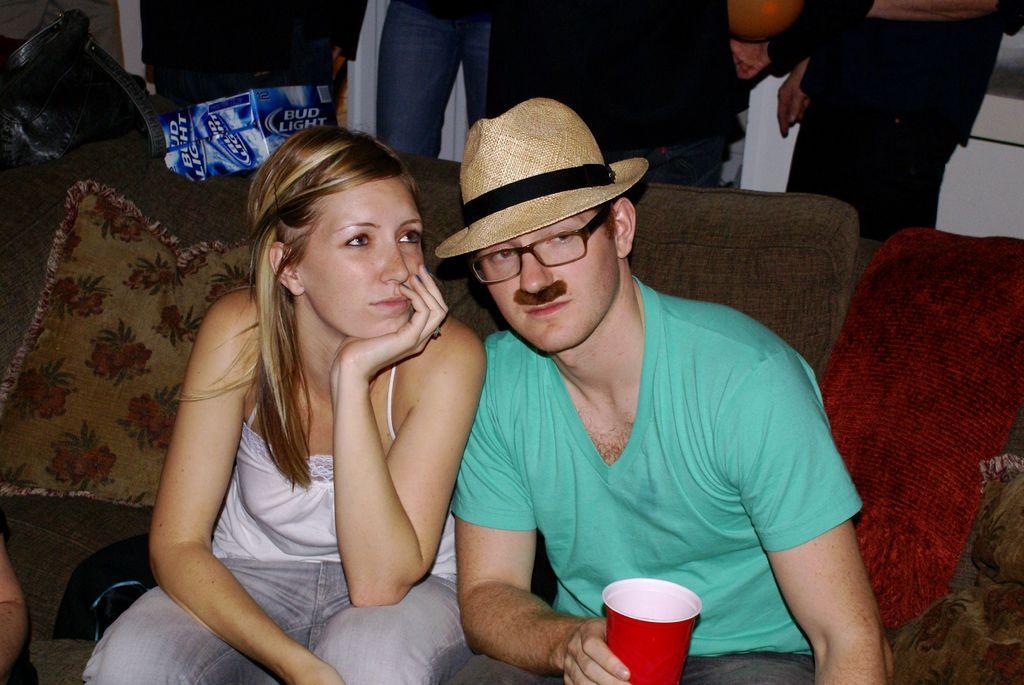Describe this image in one or two sentences. In this picture, we can see one boy and one girl is sitting on the couch and holding a cup and wearing a cap. 